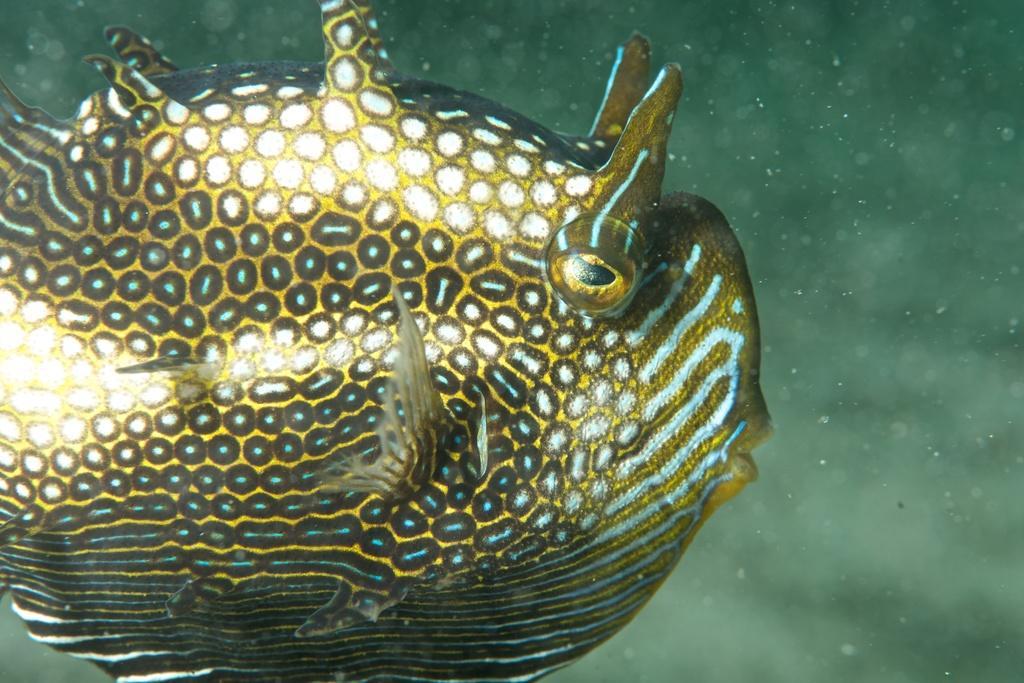In one or two sentences, can you explain what this image depicts? In this picture we can see an underwater environment, on the left side there is a fish. 